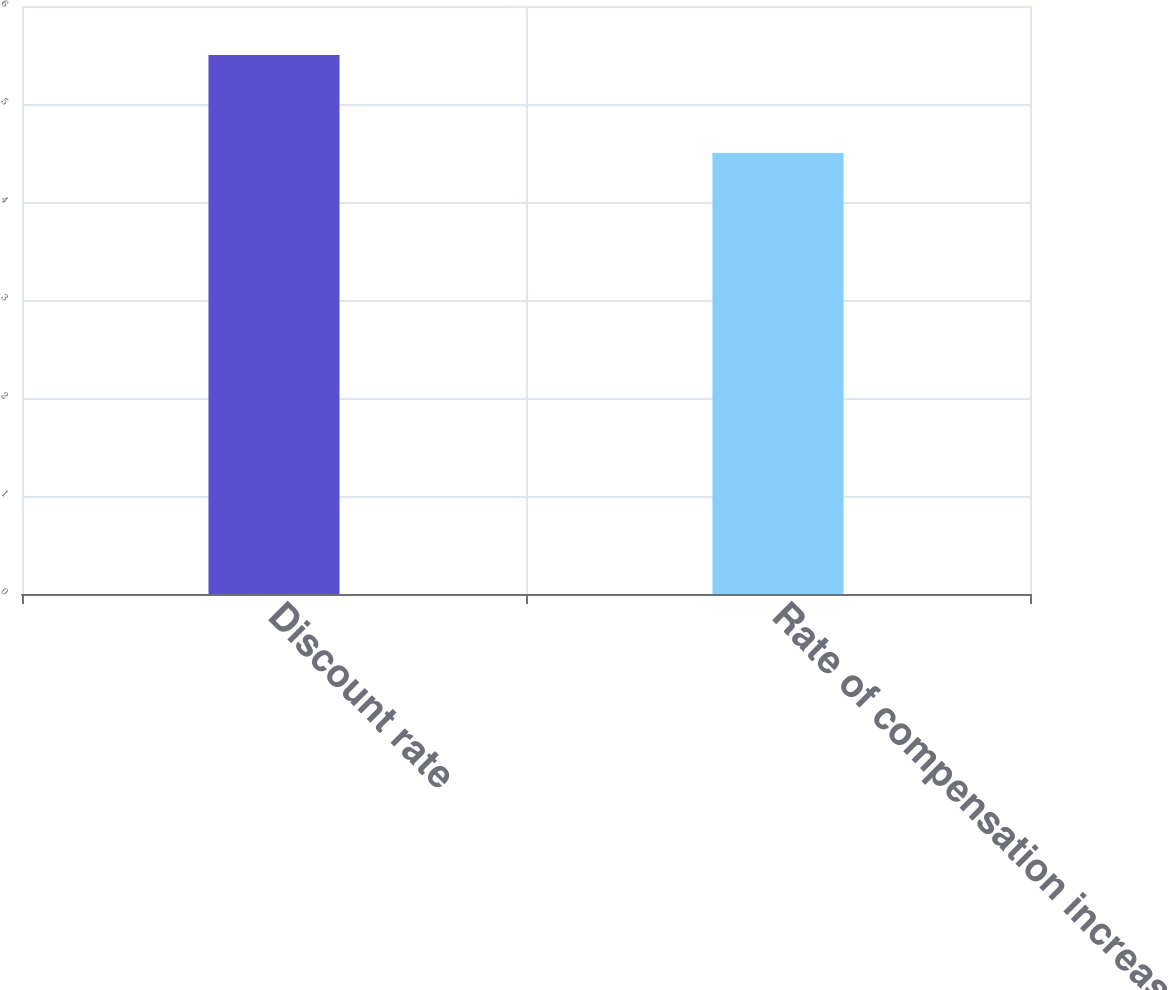Convert chart to OTSL. <chart><loc_0><loc_0><loc_500><loc_500><bar_chart><fcel>Discount rate<fcel>Rate of compensation increase<nl><fcel>5.5<fcel>4.5<nl></chart> 